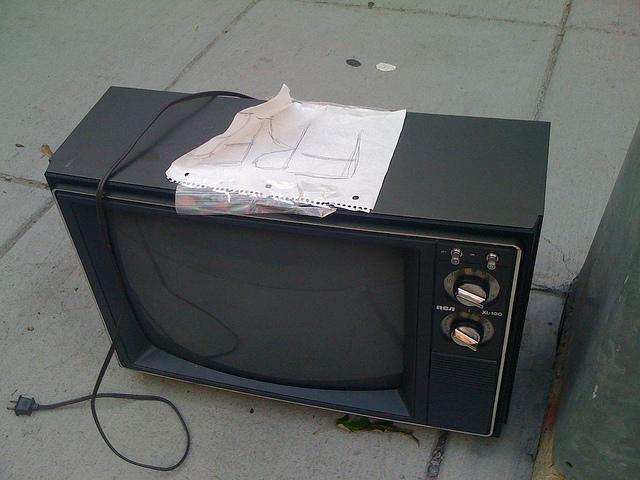How many knobs are there?
Give a very brief answer. 4. How many glasses are full of orange juice?
Give a very brief answer. 0. 